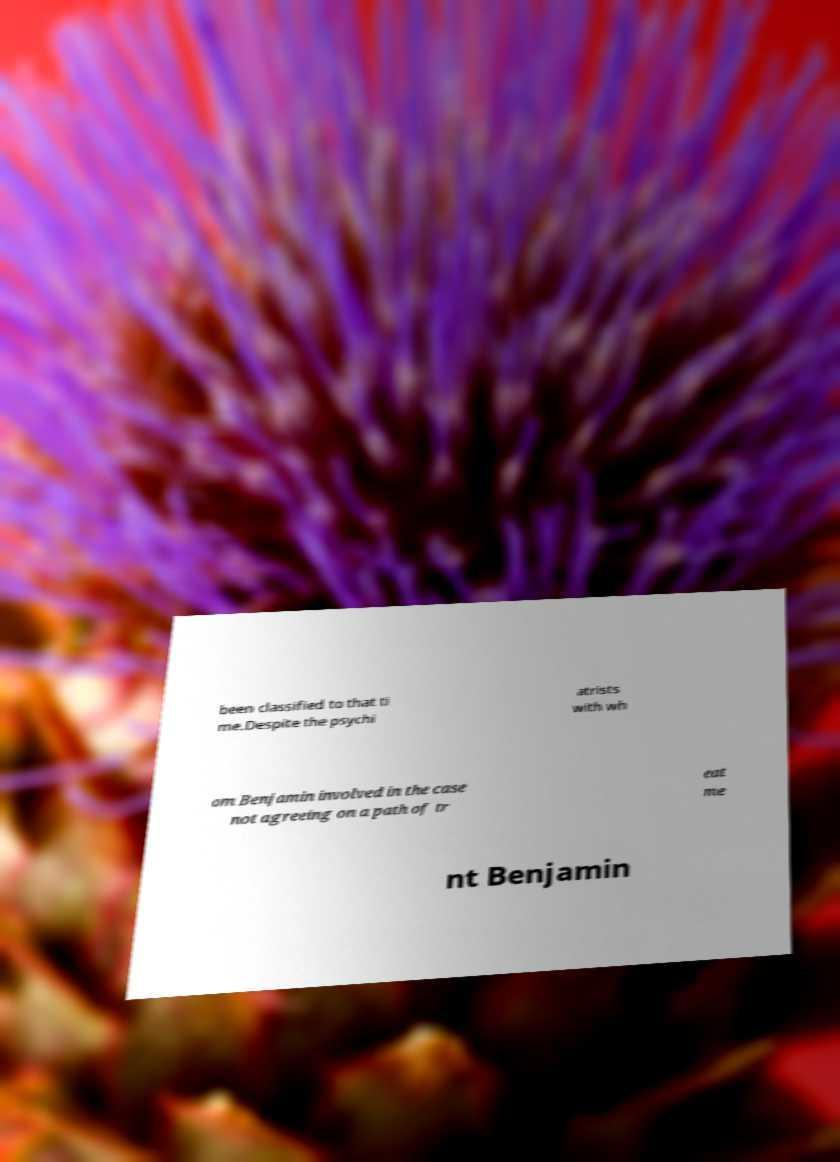Can you read and provide the text displayed in the image?This photo seems to have some interesting text. Can you extract and type it out for me? been classified to that ti me.Despite the psychi atrists with wh om Benjamin involved in the case not agreeing on a path of tr eat me nt Benjamin 